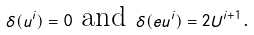<formula> <loc_0><loc_0><loc_500><loc_500>\delta ( u ^ { i } ) = 0 \text { and } \delta ( e u ^ { i } ) = 2 U ^ { i + 1 } \text {.}</formula> 